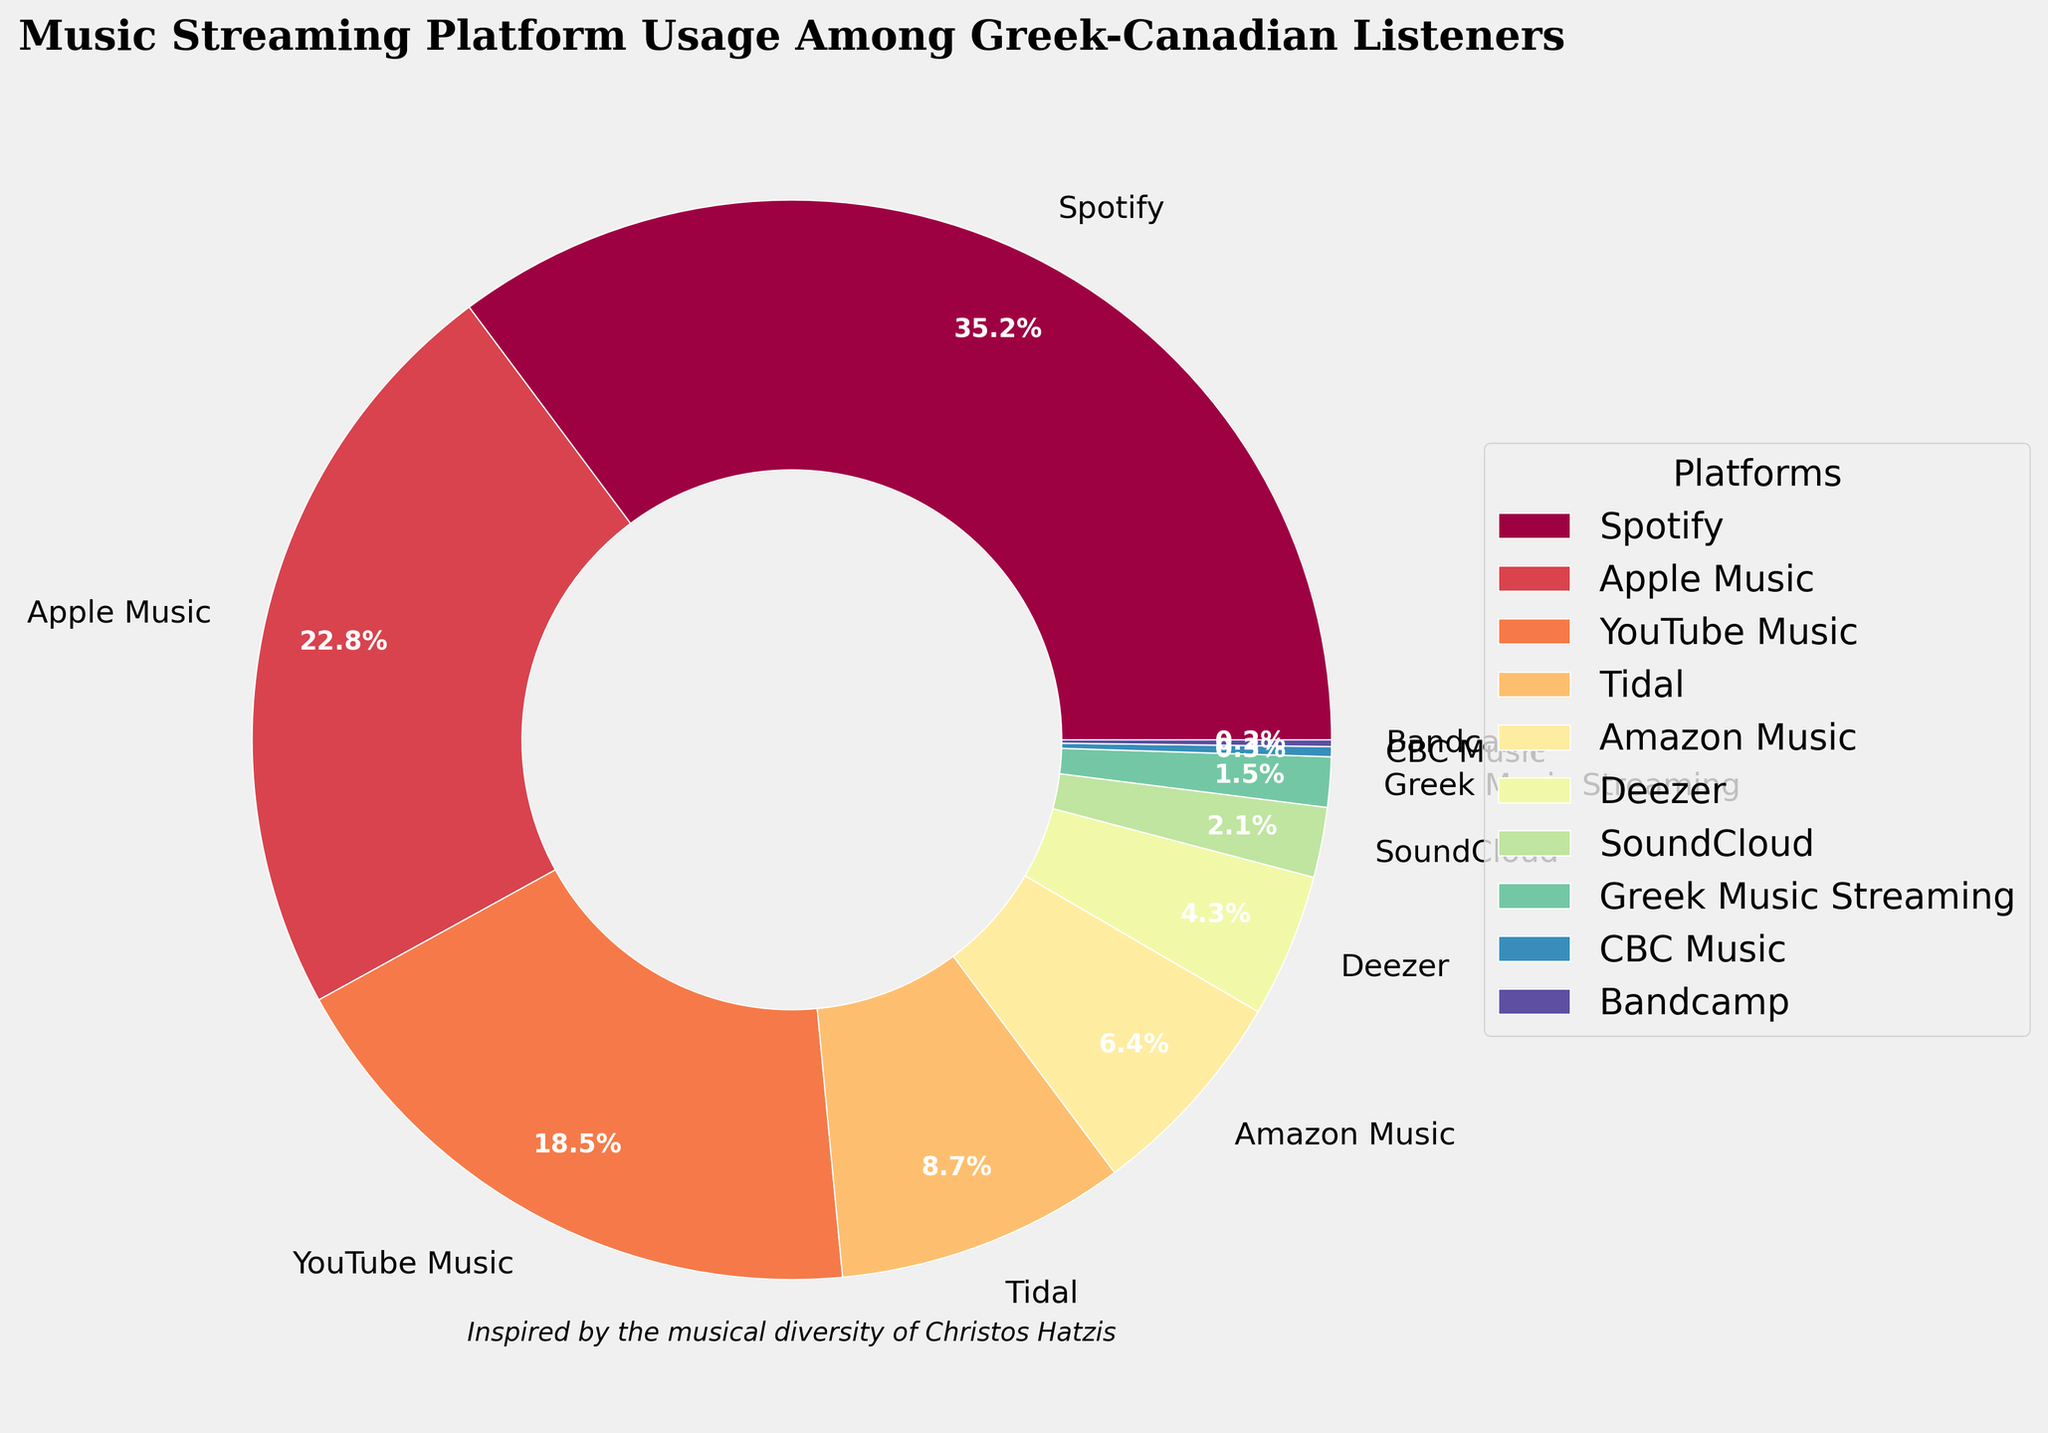What percentage of Greek-Canadian listeners use Apple Music? The pie chart shows the percentage of users for each platform, and we can directly read the value corresponding to Apple Music.
Answer: 22.8% Which music streaming platform has the smallest usage among Greek-Canadian listeners? The platforms' usage is listed in descending order, and the smallest segment on the pie chart corresponds to Bandcamp.
Answer: Bandcamp How much more popular is Spotify compared to YouTube Music among Greek-Canadian listeners? Spotify has a usage percentage of 35.2%, and YouTube Music has 18.5%. Subtract the YouTube Music percentage from the Spotify percentage: 35.2 - 18.5 = 16.7.
Answer: 16.7% What is the combined percentage of listeners using Tidal and Amazon Music? Tidal has 8.7% and Amazon Music has 6.4%. Add the two percentages together: 8.7 + 6.4 = 15.1.
Answer: 15.1% Among the platforms listed, which ones have a usage percentage below 5%? According to the chart, the platforms with percentages below 5% are Deezer (4.3%), SoundCloud (2.1%), Greek Music Streaming (1.5%), CBC Music (0.3%), and Bandcamp (0.2%).
Answer: Deezer, SoundCloud, Greek Music Streaming, CBC Music, Bandcamp Is the usage of Apple Music higher or lower than the usage of Spotify? By how much? Apple Music has 22.8% and Spotify has 35.2%. Subtract the Apple Music percentage from the Spotify percentage: 35.2 - 22.8 = 12.4. Spotify's usage is higher by 12.4%.
Answer: Higher by 12.4% What is the percentage difference between YouTube Music and Tidal? The percentage for YouTube Music is 18.5%, and for Tidal it's 8.7%. Subtract Tidal's percentage from YouTube Music's: 18.5 - 8.7 = 9.8.
Answer: 9.8% Which music streaming platforms have a higher usage percentage than Amazon Music? The platforms with higher usage percentages than Amazon Music (6.4%) are Spotify (35.2%), Apple Music (22.8%), YouTube Music (18.5%), and Tidal (8.7%).
Answer: Spotify, Apple Music, YouTube Music, Tidal What is the percentage of listeners using platforms other than Spotify, Apple Music, and YouTube Music? Add the percentages of Spotify (35.2%), Apple Music (22.8%), and YouTube Music (18.5%). Then subtract their total from 100%: 100 - (35.2 + 22.8 + 18.5) = 23.5.
Answer: 23.5% How does the popularity of Deezer compare to SoundCloud in terms of usage percentage? Deezer has a usage percentage of 4.3%, and SoundCloud has 2.1%. Subtract SoundCloud's usage from Deezer's: 4.3 - 2.1 = 2.2.
Answer: Deezer is 2.2% more popular 